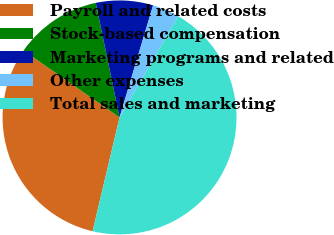Convert chart. <chart><loc_0><loc_0><loc_500><loc_500><pie_chart><fcel>Payroll and related costs<fcel>Stock-based compensation<fcel>Marketing programs and related<fcel>Other expenses<fcel>Total sales and marketing<nl><fcel>30.98%<fcel>12.05%<fcel>7.89%<fcel>3.73%<fcel>45.34%<nl></chart> 